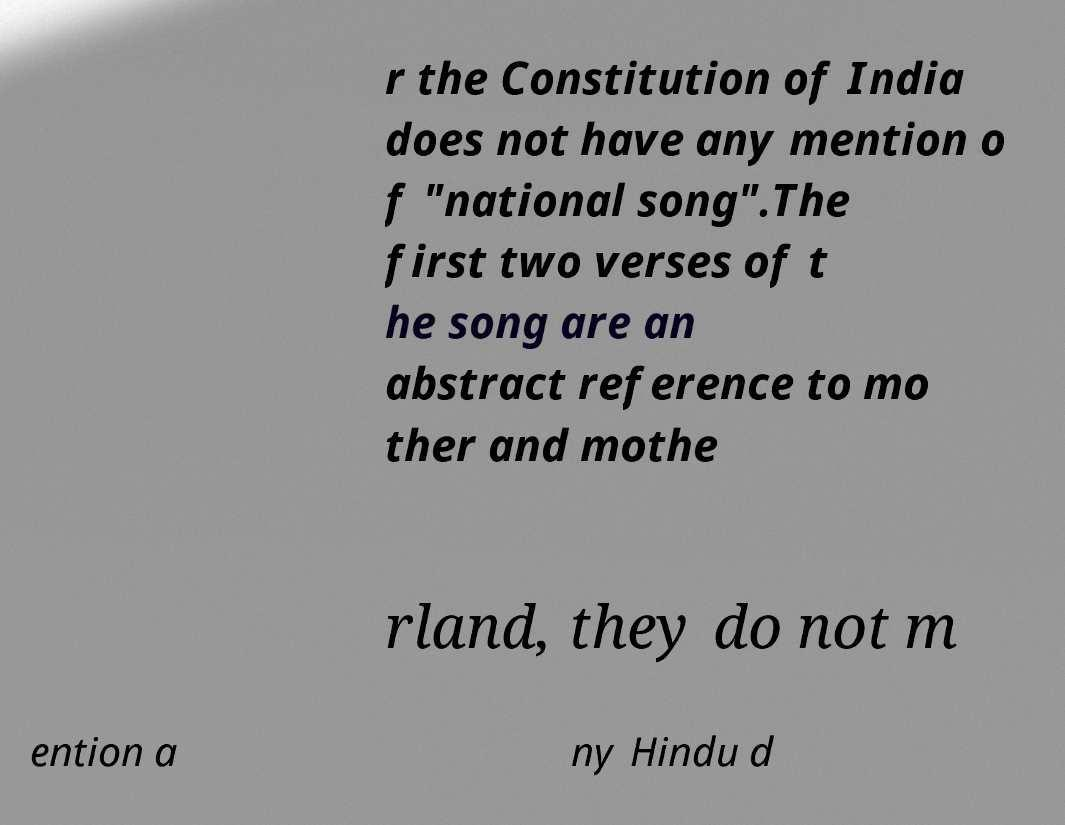I need the written content from this picture converted into text. Can you do that? r the Constitution of India does not have any mention o f "national song".The first two verses of t he song are an abstract reference to mo ther and mothe rland, they do not m ention a ny Hindu d 